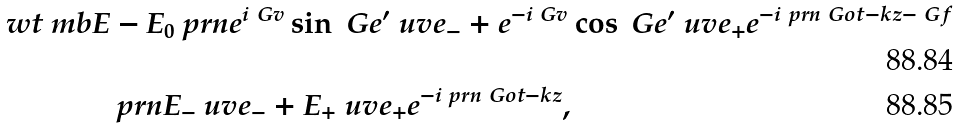Convert formula to latex. <formula><loc_0><loc_0><loc_500><loc_500>\ w t { \ m b { E } } & - E _ { 0 } \ p r n { e ^ { i \ G v } \sin \ G e ^ { \prime } \ u v { e } _ { - } + e ^ { - i \ G v } \cos \ G e ^ { \prime } \ u v { e } _ { + } } e ^ { - i \ p r n { \ G o t - k z - \ G f } } \\ & \ p r n { E _ { - } \ u v { e } _ { - } + E _ { + } \ u v { e } _ { + } } e ^ { - i \ p r n { \ G o t - k z } } ,</formula> 